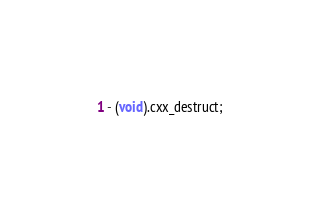<code> <loc_0><loc_0><loc_500><loc_500><_C_>- (void).cxx_destruct;</code> 